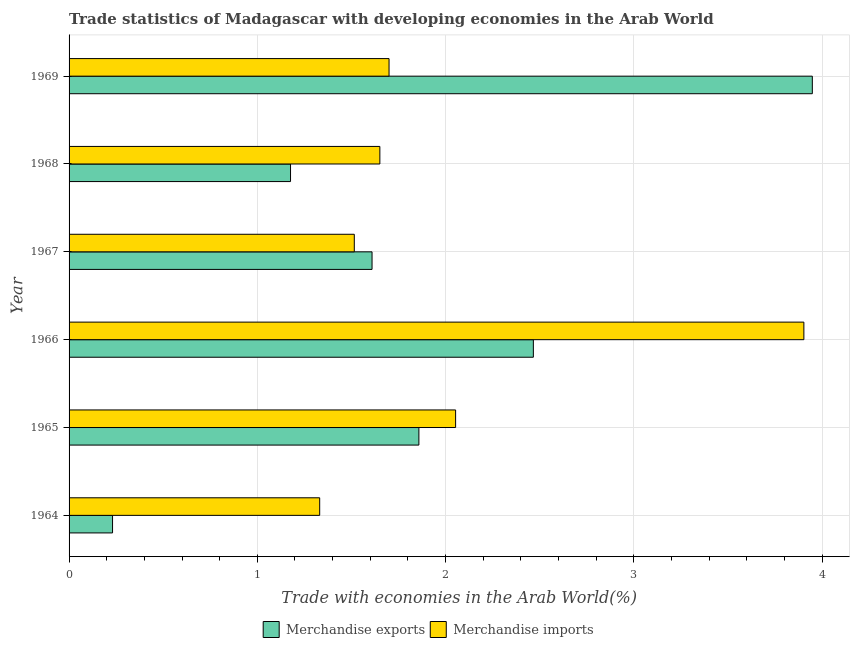How many different coloured bars are there?
Your answer should be compact. 2. Are the number of bars per tick equal to the number of legend labels?
Provide a succinct answer. Yes. Are the number of bars on each tick of the Y-axis equal?
Your response must be concise. Yes. How many bars are there on the 3rd tick from the top?
Offer a terse response. 2. What is the label of the 4th group of bars from the top?
Your answer should be very brief. 1966. In how many cases, is the number of bars for a given year not equal to the number of legend labels?
Give a very brief answer. 0. What is the merchandise exports in 1969?
Your answer should be very brief. 3.95. Across all years, what is the maximum merchandise imports?
Give a very brief answer. 3.9. Across all years, what is the minimum merchandise exports?
Your answer should be very brief. 0.23. In which year was the merchandise imports maximum?
Your answer should be compact. 1966. In which year was the merchandise imports minimum?
Ensure brevity in your answer.  1964. What is the total merchandise exports in the graph?
Ensure brevity in your answer.  11.29. What is the difference between the merchandise exports in 1967 and that in 1968?
Give a very brief answer. 0.43. What is the difference between the merchandise exports in 1966 and the merchandise imports in 1964?
Offer a very short reply. 1.14. What is the average merchandise imports per year?
Your answer should be compact. 2.03. What is the ratio of the merchandise exports in 1968 to that in 1969?
Your answer should be very brief. 0.3. Is the difference between the merchandise imports in 1964 and 1969 greater than the difference between the merchandise exports in 1964 and 1969?
Make the answer very short. Yes. What is the difference between the highest and the second highest merchandise imports?
Offer a very short reply. 1.85. What is the difference between the highest and the lowest merchandise exports?
Your response must be concise. 3.72. Are all the bars in the graph horizontal?
Offer a terse response. Yes. Does the graph contain grids?
Provide a short and direct response. Yes. How are the legend labels stacked?
Your response must be concise. Horizontal. What is the title of the graph?
Provide a succinct answer. Trade statistics of Madagascar with developing economies in the Arab World. What is the label or title of the X-axis?
Provide a succinct answer. Trade with economies in the Arab World(%). What is the Trade with economies in the Arab World(%) of Merchandise exports in 1964?
Offer a terse response. 0.23. What is the Trade with economies in the Arab World(%) in Merchandise imports in 1964?
Provide a succinct answer. 1.33. What is the Trade with economies in the Arab World(%) of Merchandise exports in 1965?
Offer a very short reply. 1.86. What is the Trade with economies in the Arab World(%) of Merchandise imports in 1965?
Offer a very short reply. 2.05. What is the Trade with economies in the Arab World(%) of Merchandise exports in 1966?
Provide a short and direct response. 2.47. What is the Trade with economies in the Arab World(%) of Merchandise imports in 1966?
Provide a succinct answer. 3.9. What is the Trade with economies in the Arab World(%) in Merchandise exports in 1967?
Keep it short and to the point. 1.61. What is the Trade with economies in the Arab World(%) of Merchandise imports in 1967?
Provide a short and direct response. 1.52. What is the Trade with economies in the Arab World(%) of Merchandise exports in 1968?
Ensure brevity in your answer.  1.18. What is the Trade with economies in the Arab World(%) of Merchandise imports in 1968?
Provide a short and direct response. 1.65. What is the Trade with economies in the Arab World(%) of Merchandise exports in 1969?
Make the answer very short. 3.95. What is the Trade with economies in the Arab World(%) of Merchandise imports in 1969?
Ensure brevity in your answer.  1.7. Across all years, what is the maximum Trade with economies in the Arab World(%) of Merchandise exports?
Give a very brief answer. 3.95. Across all years, what is the maximum Trade with economies in the Arab World(%) in Merchandise imports?
Offer a very short reply. 3.9. Across all years, what is the minimum Trade with economies in the Arab World(%) of Merchandise exports?
Offer a very short reply. 0.23. Across all years, what is the minimum Trade with economies in the Arab World(%) of Merchandise imports?
Your response must be concise. 1.33. What is the total Trade with economies in the Arab World(%) of Merchandise exports in the graph?
Offer a very short reply. 11.29. What is the total Trade with economies in the Arab World(%) in Merchandise imports in the graph?
Provide a short and direct response. 12.15. What is the difference between the Trade with economies in the Arab World(%) of Merchandise exports in 1964 and that in 1965?
Give a very brief answer. -1.63. What is the difference between the Trade with economies in the Arab World(%) in Merchandise imports in 1964 and that in 1965?
Keep it short and to the point. -0.72. What is the difference between the Trade with economies in the Arab World(%) in Merchandise exports in 1964 and that in 1966?
Give a very brief answer. -2.24. What is the difference between the Trade with economies in the Arab World(%) of Merchandise imports in 1964 and that in 1966?
Your answer should be very brief. -2.57. What is the difference between the Trade with economies in the Arab World(%) of Merchandise exports in 1964 and that in 1967?
Keep it short and to the point. -1.38. What is the difference between the Trade with economies in the Arab World(%) of Merchandise imports in 1964 and that in 1967?
Give a very brief answer. -0.18. What is the difference between the Trade with economies in the Arab World(%) of Merchandise exports in 1964 and that in 1968?
Keep it short and to the point. -0.95. What is the difference between the Trade with economies in the Arab World(%) of Merchandise imports in 1964 and that in 1968?
Offer a terse response. -0.32. What is the difference between the Trade with economies in the Arab World(%) of Merchandise exports in 1964 and that in 1969?
Offer a very short reply. -3.72. What is the difference between the Trade with economies in the Arab World(%) in Merchandise imports in 1964 and that in 1969?
Offer a very short reply. -0.37. What is the difference between the Trade with economies in the Arab World(%) of Merchandise exports in 1965 and that in 1966?
Ensure brevity in your answer.  -0.61. What is the difference between the Trade with economies in the Arab World(%) in Merchandise imports in 1965 and that in 1966?
Ensure brevity in your answer.  -1.85. What is the difference between the Trade with economies in the Arab World(%) of Merchandise exports in 1965 and that in 1967?
Offer a very short reply. 0.25. What is the difference between the Trade with economies in the Arab World(%) in Merchandise imports in 1965 and that in 1967?
Give a very brief answer. 0.54. What is the difference between the Trade with economies in the Arab World(%) of Merchandise exports in 1965 and that in 1968?
Provide a succinct answer. 0.68. What is the difference between the Trade with economies in the Arab World(%) in Merchandise imports in 1965 and that in 1968?
Keep it short and to the point. 0.4. What is the difference between the Trade with economies in the Arab World(%) in Merchandise exports in 1965 and that in 1969?
Offer a very short reply. -2.09. What is the difference between the Trade with economies in the Arab World(%) in Merchandise imports in 1965 and that in 1969?
Provide a short and direct response. 0.35. What is the difference between the Trade with economies in the Arab World(%) of Merchandise exports in 1966 and that in 1967?
Give a very brief answer. 0.86. What is the difference between the Trade with economies in the Arab World(%) in Merchandise imports in 1966 and that in 1967?
Your answer should be compact. 2.39. What is the difference between the Trade with economies in the Arab World(%) of Merchandise exports in 1966 and that in 1968?
Offer a terse response. 1.29. What is the difference between the Trade with economies in the Arab World(%) of Merchandise imports in 1966 and that in 1968?
Give a very brief answer. 2.25. What is the difference between the Trade with economies in the Arab World(%) of Merchandise exports in 1966 and that in 1969?
Offer a very short reply. -1.48. What is the difference between the Trade with economies in the Arab World(%) of Merchandise imports in 1966 and that in 1969?
Your answer should be compact. 2.2. What is the difference between the Trade with economies in the Arab World(%) of Merchandise exports in 1967 and that in 1968?
Make the answer very short. 0.43. What is the difference between the Trade with economies in the Arab World(%) of Merchandise imports in 1967 and that in 1968?
Offer a very short reply. -0.14. What is the difference between the Trade with economies in the Arab World(%) in Merchandise exports in 1967 and that in 1969?
Ensure brevity in your answer.  -2.34. What is the difference between the Trade with economies in the Arab World(%) in Merchandise imports in 1967 and that in 1969?
Keep it short and to the point. -0.18. What is the difference between the Trade with economies in the Arab World(%) in Merchandise exports in 1968 and that in 1969?
Keep it short and to the point. -2.77. What is the difference between the Trade with economies in the Arab World(%) in Merchandise imports in 1968 and that in 1969?
Offer a terse response. -0.05. What is the difference between the Trade with economies in the Arab World(%) in Merchandise exports in 1964 and the Trade with economies in the Arab World(%) in Merchandise imports in 1965?
Provide a succinct answer. -1.82. What is the difference between the Trade with economies in the Arab World(%) in Merchandise exports in 1964 and the Trade with economies in the Arab World(%) in Merchandise imports in 1966?
Give a very brief answer. -3.67. What is the difference between the Trade with economies in the Arab World(%) in Merchandise exports in 1964 and the Trade with economies in the Arab World(%) in Merchandise imports in 1967?
Your answer should be compact. -1.28. What is the difference between the Trade with economies in the Arab World(%) in Merchandise exports in 1964 and the Trade with economies in the Arab World(%) in Merchandise imports in 1968?
Provide a short and direct response. -1.42. What is the difference between the Trade with economies in the Arab World(%) of Merchandise exports in 1964 and the Trade with economies in the Arab World(%) of Merchandise imports in 1969?
Provide a short and direct response. -1.47. What is the difference between the Trade with economies in the Arab World(%) of Merchandise exports in 1965 and the Trade with economies in the Arab World(%) of Merchandise imports in 1966?
Keep it short and to the point. -2.05. What is the difference between the Trade with economies in the Arab World(%) in Merchandise exports in 1965 and the Trade with economies in the Arab World(%) in Merchandise imports in 1967?
Keep it short and to the point. 0.34. What is the difference between the Trade with economies in the Arab World(%) of Merchandise exports in 1965 and the Trade with economies in the Arab World(%) of Merchandise imports in 1968?
Offer a very short reply. 0.21. What is the difference between the Trade with economies in the Arab World(%) of Merchandise exports in 1965 and the Trade with economies in the Arab World(%) of Merchandise imports in 1969?
Ensure brevity in your answer.  0.16. What is the difference between the Trade with economies in the Arab World(%) of Merchandise exports in 1966 and the Trade with economies in the Arab World(%) of Merchandise imports in 1967?
Offer a very short reply. 0.95. What is the difference between the Trade with economies in the Arab World(%) in Merchandise exports in 1966 and the Trade with economies in the Arab World(%) in Merchandise imports in 1968?
Offer a very short reply. 0.82. What is the difference between the Trade with economies in the Arab World(%) of Merchandise exports in 1966 and the Trade with economies in the Arab World(%) of Merchandise imports in 1969?
Your response must be concise. 0.77. What is the difference between the Trade with economies in the Arab World(%) of Merchandise exports in 1967 and the Trade with economies in the Arab World(%) of Merchandise imports in 1968?
Make the answer very short. -0.04. What is the difference between the Trade with economies in the Arab World(%) of Merchandise exports in 1967 and the Trade with economies in the Arab World(%) of Merchandise imports in 1969?
Give a very brief answer. -0.09. What is the difference between the Trade with economies in the Arab World(%) in Merchandise exports in 1968 and the Trade with economies in the Arab World(%) in Merchandise imports in 1969?
Ensure brevity in your answer.  -0.52. What is the average Trade with economies in the Arab World(%) of Merchandise exports per year?
Your answer should be very brief. 1.88. What is the average Trade with economies in the Arab World(%) of Merchandise imports per year?
Give a very brief answer. 2.03. In the year 1964, what is the difference between the Trade with economies in the Arab World(%) of Merchandise exports and Trade with economies in the Arab World(%) of Merchandise imports?
Offer a terse response. -1.1. In the year 1965, what is the difference between the Trade with economies in the Arab World(%) of Merchandise exports and Trade with economies in the Arab World(%) of Merchandise imports?
Keep it short and to the point. -0.2. In the year 1966, what is the difference between the Trade with economies in the Arab World(%) of Merchandise exports and Trade with economies in the Arab World(%) of Merchandise imports?
Provide a succinct answer. -1.44. In the year 1967, what is the difference between the Trade with economies in the Arab World(%) in Merchandise exports and Trade with economies in the Arab World(%) in Merchandise imports?
Your answer should be very brief. 0.09. In the year 1968, what is the difference between the Trade with economies in the Arab World(%) in Merchandise exports and Trade with economies in the Arab World(%) in Merchandise imports?
Your answer should be compact. -0.47. In the year 1969, what is the difference between the Trade with economies in the Arab World(%) in Merchandise exports and Trade with economies in the Arab World(%) in Merchandise imports?
Your response must be concise. 2.25. What is the ratio of the Trade with economies in the Arab World(%) of Merchandise exports in 1964 to that in 1965?
Make the answer very short. 0.12. What is the ratio of the Trade with economies in the Arab World(%) in Merchandise imports in 1964 to that in 1965?
Provide a succinct answer. 0.65. What is the ratio of the Trade with economies in the Arab World(%) of Merchandise exports in 1964 to that in 1966?
Your answer should be compact. 0.09. What is the ratio of the Trade with economies in the Arab World(%) in Merchandise imports in 1964 to that in 1966?
Give a very brief answer. 0.34. What is the ratio of the Trade with economies in the Arab World(%) in Merchandise exports in 1964 to that in 1967?
Your answer should be compact. 0.14. What is the ratio of the Trade with economies in the Arab World(%) of Merchandise imports in 1964 to that in 1967?
Your response must be concise. 0.88. What is the ratio of the Trade with economies in the Arab World(%) in Merchandise exports in 1964 to that in 1968?
Provide a succinct answer. 0.2. What is the ratio of the Trade with economies in the Arab World(%) of Merchandise imports in 1964 to that in 1968?
Provide a succinct answer. 0.81. What is the ratio of the Trade with economies in the Arab World(%) of Merchandise exports in 1964 to that in 1969?
Provide a short and direct response. 0.06. What is the ratio of the Trade with economies in the Arab World(%) in Merchandise imports in 1964 to that in 1969?
Provide a succinct answer. 0.78. What is the ratio of the Trade with economies in the Arab World(%) in Merchandise exports in 1965 to that in 1966?
Your answer should be compact. 0.75. What is the ratio of the Trade with economies in the Arab World(%) in Merchandise imports in 1965 to that in 1966?
Your answer should be very brief. 0.53. What is the ratio of the Trade with economies in the Arab World(%) of Merchandise exports in 1965 to that in 1967?
Your response must be concise. 1.15. What is the ratio of the Trade with economies in the Arab World(%) in Merchandise imports in 1965 to that in 1967?
Keep it short and to the point. 1.36. What is the ratio of the Trade with economies in the Arab World(%) in Merchandise exports in 1965 to that in 1968?
Your answer should be compact. 1.58. What is the ratio of the Trade with economies in the Arab World(%) in Merchandise imports in 1965 to that in 1968?
Keep it short and to the point. 1.24. What is the ratio of the Trade with economies in the Arab World(%) of Merchandise exports in 1965 to that in 1969?
Your answer should be compact. 0.47. What is the ratio of the Trade with economies in the Arab World(%) of Merchandise imports in 1965 to that in 1969?
Your answer should be very brief. 1.21. What is the ratio of the Trade with economies in the Arab World(%) of Merchandise exports in 1966 to that in 1967?
Provide a succinct answer. 1.53. What is the ratio of the Trade with economies in the Arab World(%) of Merchandise imports in 1966 to that in 1967?
Keep it short and to the point. 2.58. What is the ratio of the Trade with economies in the Arab World(%) in Merchandise exports in 1966 to that in 1968?
Your answer should be compact. 2.1. What is the ratio of the Trade with economies in the Arab World(%) in Merchandise imports in 1966 to that in 1968?
Your answer should be very brief. 2.36. What is the ratio of the Trade with economies in the Arab World(%) in Merchandise exports in 1966 to that in 1969?
Your answer should be compact. 0.62. What is the ratio of the Trade with economies in the Arab World(%) in Merchandise imports in 1966 to that in 1969?
Your response must be concise. 2.3. What is the ratio of the Trade with economies in the Arab World(%) in Merchandise exports in 1967 to that in 1968?
Your answer should be very brief. 1.37. What is the ratio of the Trade with economies in the Arab World(%) in Merchandise imports in 1967 to that in 1968?
Provide a short and direct response. 0.92. What is the ratio of the Trade with economies in the Arab World(%) of Merchandise exports in 1967 to that in 1969?
Your response must be concise. 0.41. What is the ratio of the Trade with economies in the Arab World(%) of Merchandise imports in 1967 to that in 1969?
Provide a short and direct response. 0.89. What is the ratio of the Trade with economies in the Arab World(%) of Merchandise exports in 1968 to that in 1969?
Your answer should be very brief. 0.3. What is the ratio of the Trade with economies in the Arab World(%) in Merchandise imports in 1968 to that in 1969?
Your answer should be compact. 0.97. What is the difference between the highest and the second highest Trade with economies in the Arab World(%) of Merchandise exports?
Your response must be concise. 1.48. What is the difference between the highest and the second highest Trade with economies in the Arab World(%) of Merchandise imports?
Make the answer very short. 1.85. What is the difference between the highest and the lowest Trade with economies in the Arab World(%) in Merchandise exports?
Keep it short and to the point. 3.72. What is the difference between the highest and the lowest Trade with economies in the Arab World(%) in Merchandise imports?
Give a very brief answer. 2.57. 